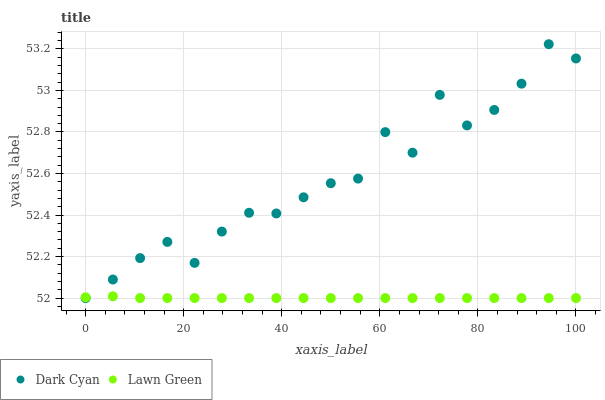Does Lawn Green have the minimum area under the curve?
Answer yes or no. Yes. Does Dark Cyan have the maximum area under the curve?
Answer yes or no. Yes. Does Lawn Green have the maximum area under the curve?
Answer yes or no. No. Is Lawn Green the smoothest?
Answer yes or no. Yes. Is Dark Cyan the roughest?
Answer yes or no. Yes. Is Lawn Green the roughest?
Answer yes or no. No. Does Dark Cyan have the lowest value?
Answer yes or no. Yes. Does Dark Cyan have the highest value?
Answer yes or no. Yes. Does Lawn Green have the highest value?
Answer yes or no. No. Does Dark Cyan intersect Lawn Green?
Answer yes or no. Yes. Is Dark Cyan less than Lawn Green?
Answer yes or no. No. Is Dark Cyan greater than Lawn Green?
Answer yes or no. No. 